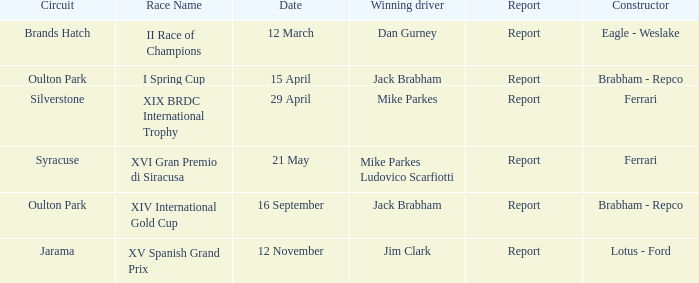What company constrcuted the vehicle with a circuit of oulton park on 15 april? Brabham - Repco. 